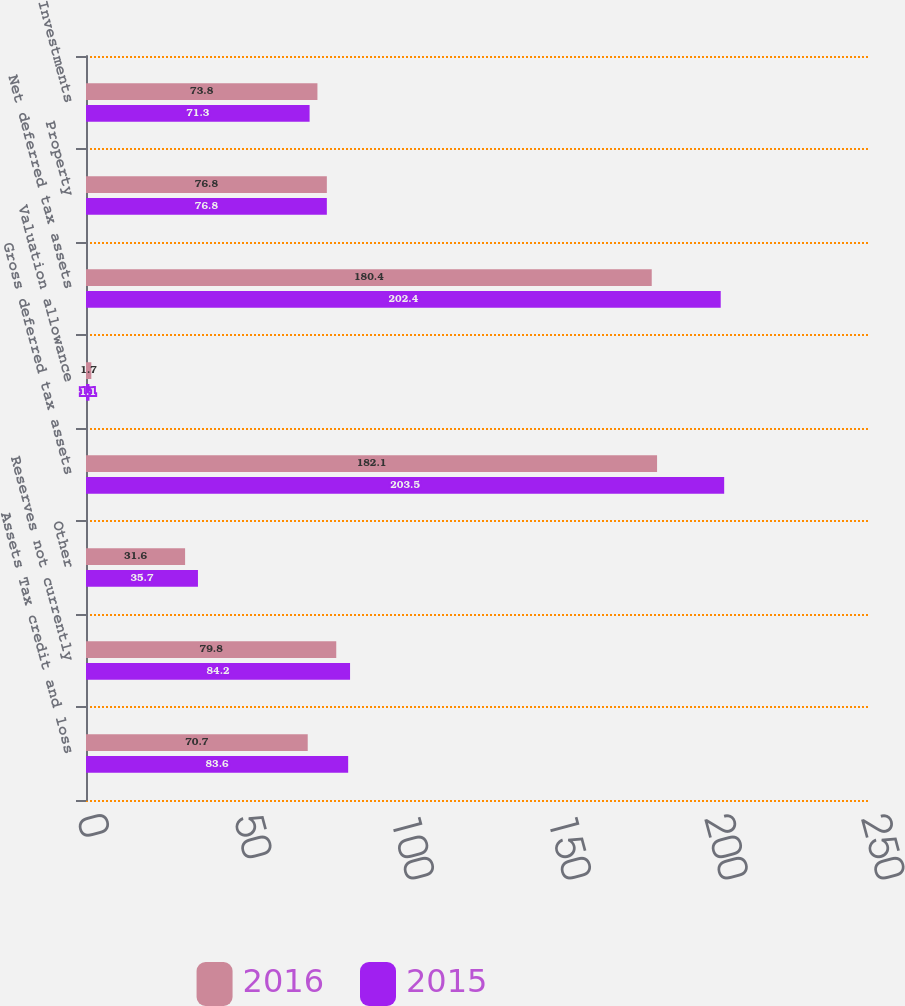Convert chart. <chart><loc_0><loc_0><loc_500><loc_500><stacked_bar_chart><ecel><fcel>Assets Tax credit and loss<fcel>Reserves not currently<fcel>Other<fcel>Gross deferred tax assets<fcel>Valuation allowance<fcel>Net deferred tax assets<fcel>Property<fcel>Investments<nl><fcel>2016<fcel>70.7<fcel>79.8<fcel>31.6<fcel>182.1<fcel>1.7<fcel>180.4<fcel>76.8<fcel>73.8<nl><fcel>2015<fcel>83.6<fcel>84.2<fcel>35.7<fcel>203.5<fcel>1.1<fcel>202.4<fcel>76.8<fcel>71.3<nl></chart> 